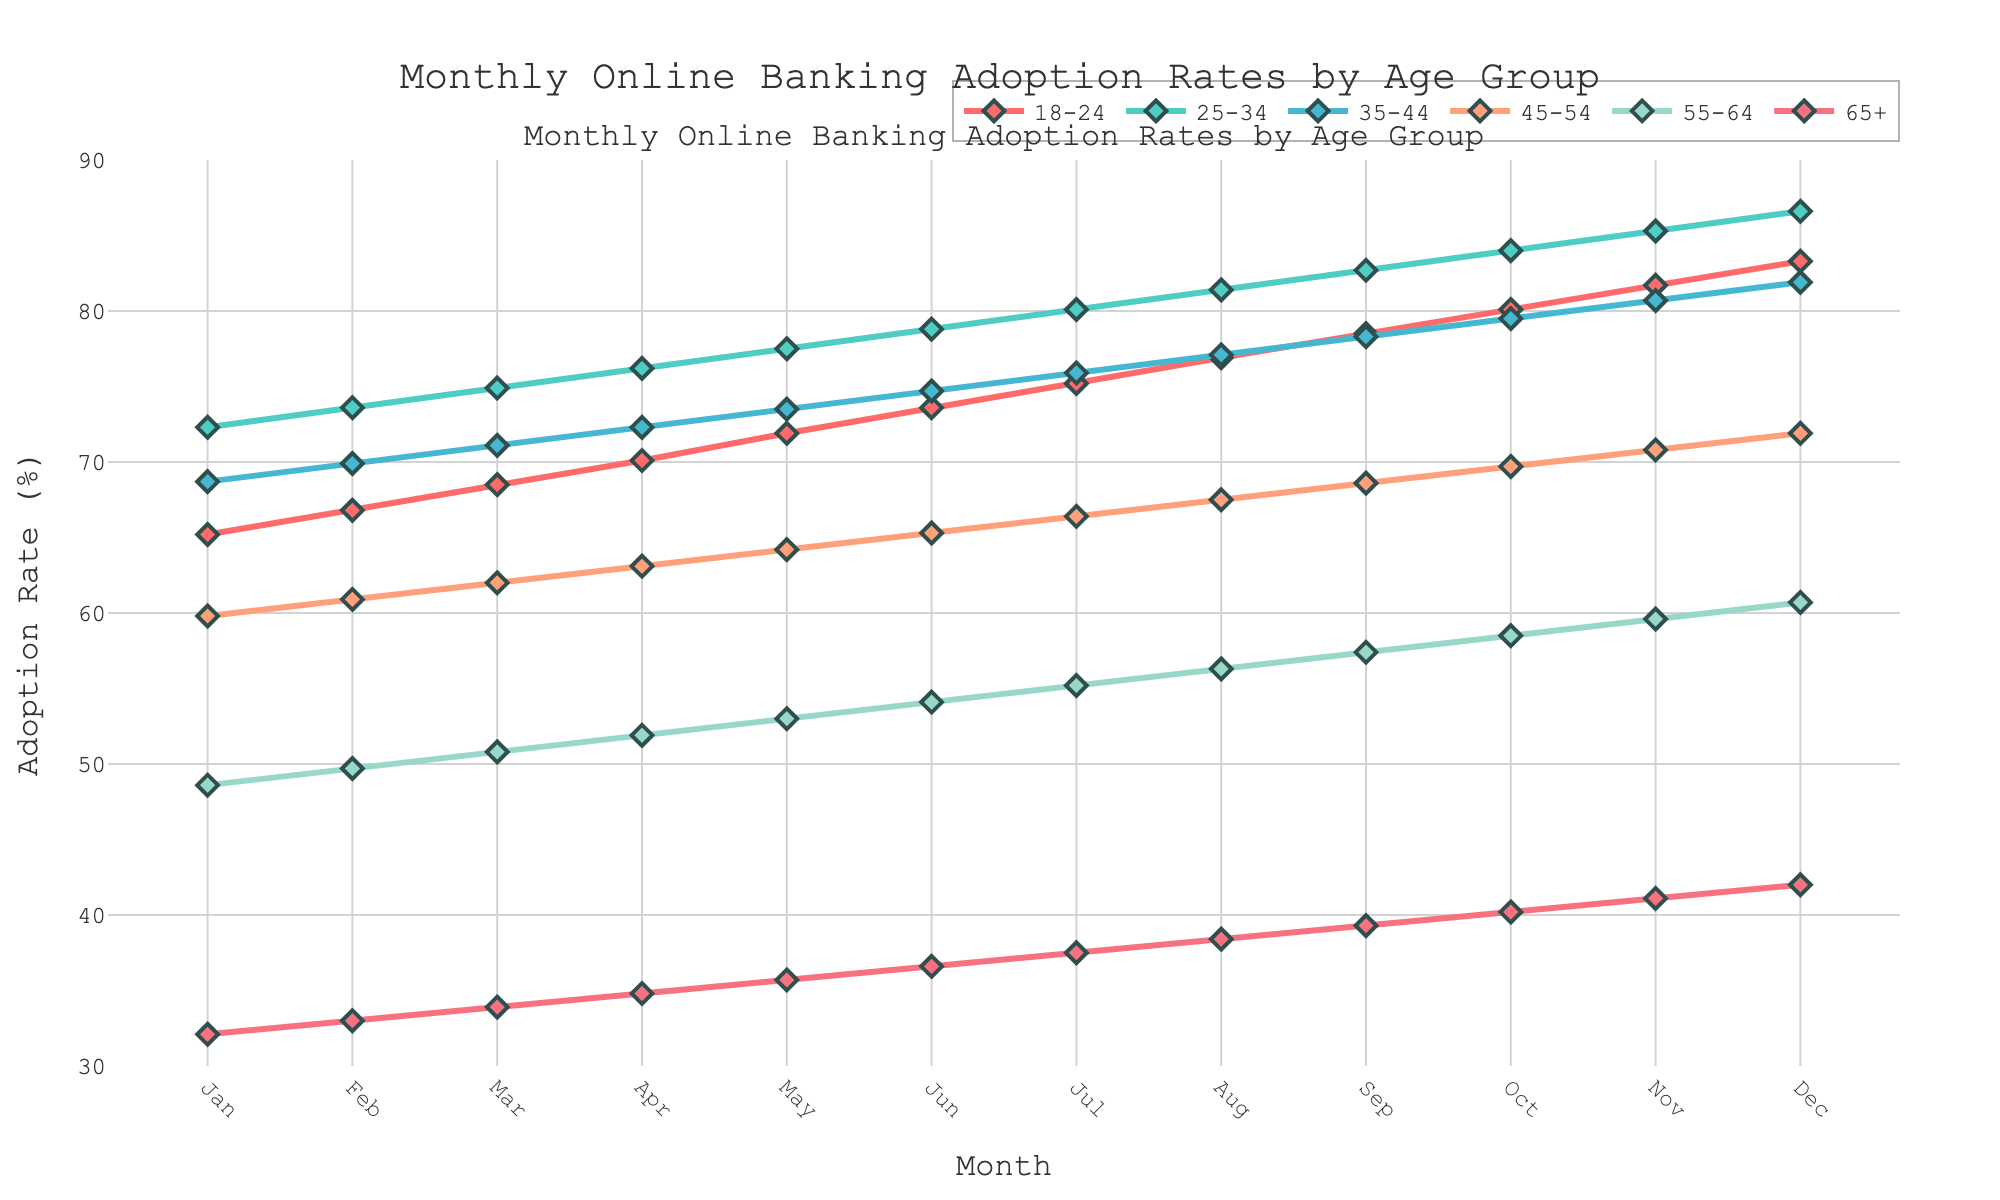At what month did the 18-24 age group surpass the 80% adoption rate? Looking at the 18-24 age group's line, find the month where the adoption rate is slightly above 80%. This occurs between September and October.
Answer: October Which age group had the highest adoption rate in January? Compare the starting points of all age groups in January. The 25-34 age group has the highest adoption rate at 72.3%.
Answer: 25-34 By how much did the 65+ age group improve their adoption rate from January to December? Subtract the January adoption rate of the 65+ group (32.1%) from the December adoption rate (42.0%). This gives 42.0% - 32.1% = 9.9%.
Answer: 9.9% Which two age groups had the smallest increase in adoption rates from January to December? Calculate the increase for each age group by subtracting January values from December values and compare them. The smallest increases are for the 35-44 (13.2%) and 45-54 (12.1%) age groups.
Answer: 35-44 and 45-54 Which age group showed the highest monthly average increase in adoption rate from January to December? Calculate the total increase from January to December for each age group and then divide by 11 (number of intervals). The 18-24 age group went from 65.2% to 83.3%, which is the highest total increase: (83.3% - 65.2%) / 11 = approximately 1.64% per month.
Answer: 18-24 During which month was the difference in adoption rate between the 25-34 and 45-54 age groups the greatest? For each month, subtract the 45-54 rate from the 25-34 rate, and find the month where this difference is maximum. The greatest difference occurs in January (72.3% - 59.8% = 12.5%).
Answer: January Which age group achieved over 70% adoption rate first? Identify the months where each age group crosses the 70% adoption threshold and find the earliest month. The 25-34 age group surpassed 70% in January.
Answer: 25-34 